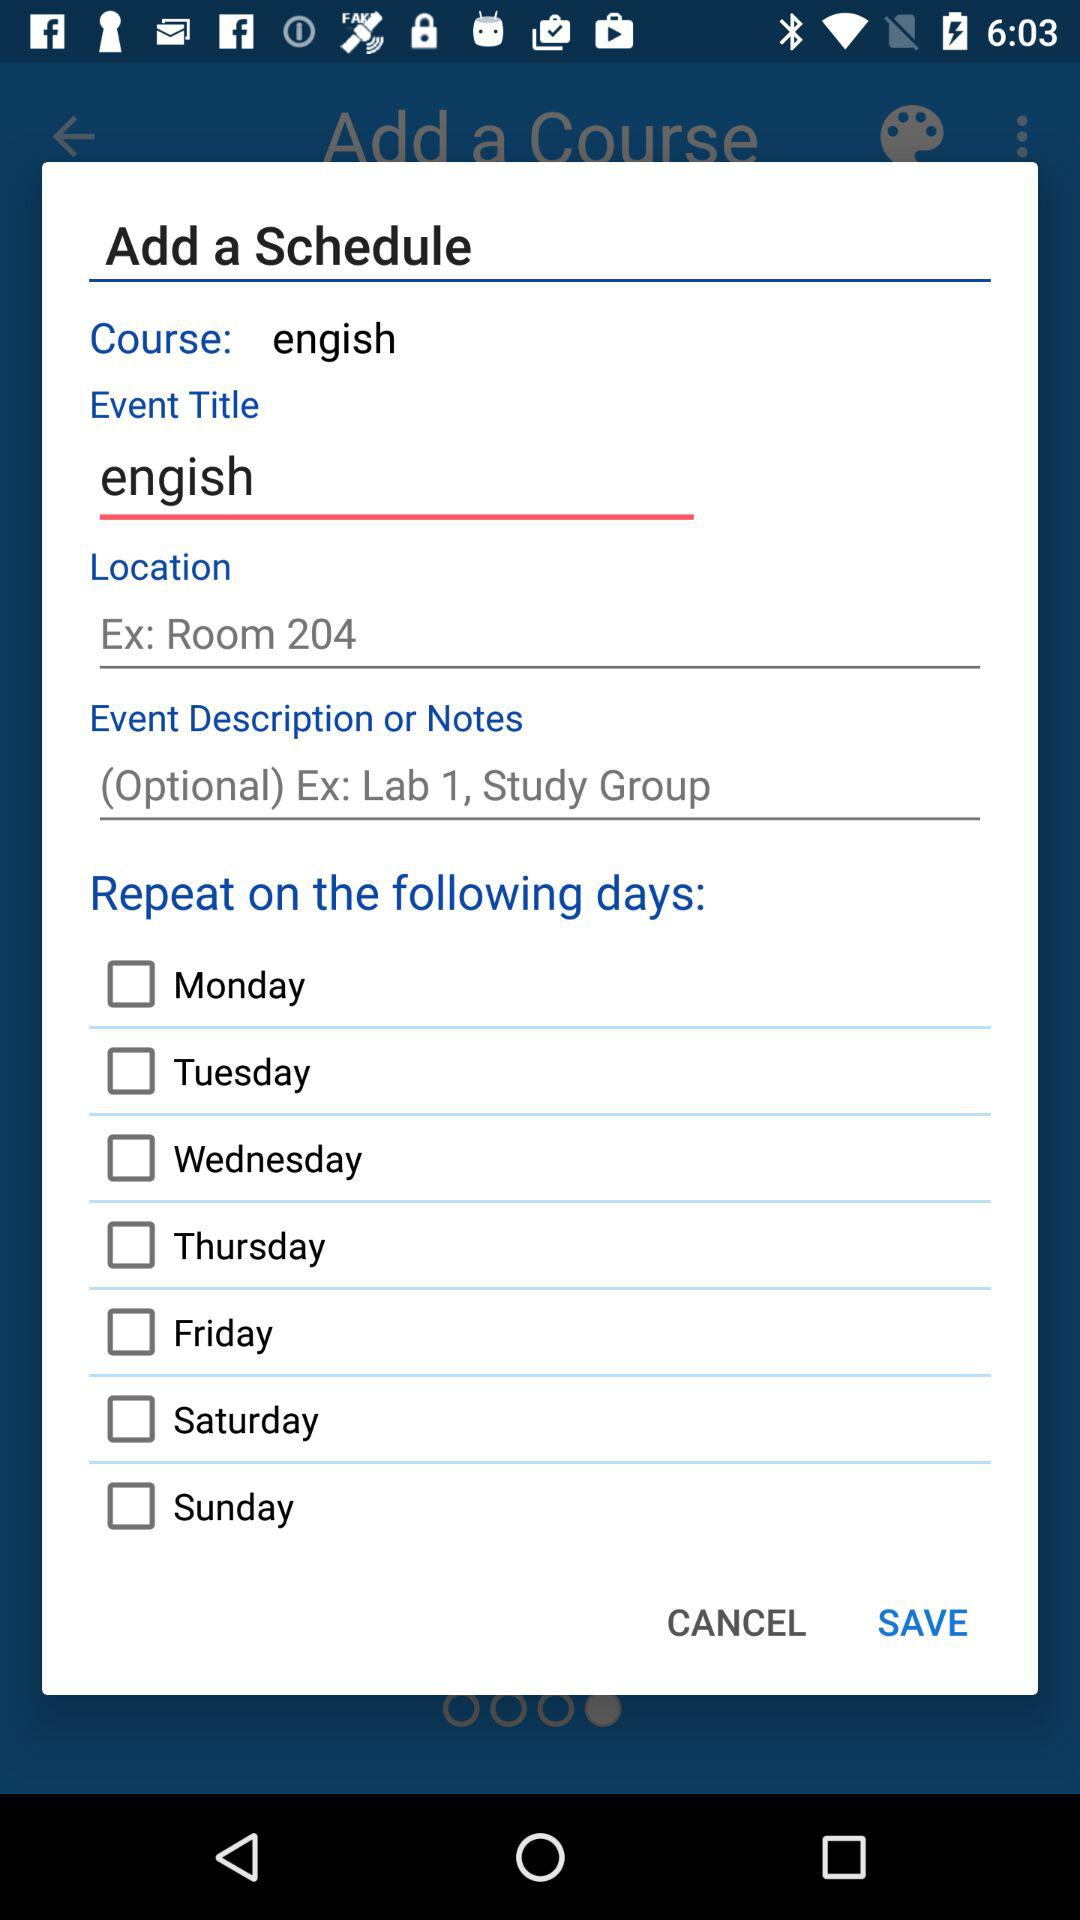How many checkboxes are unchecked?
Answer the question using a single word or phrase. 7 